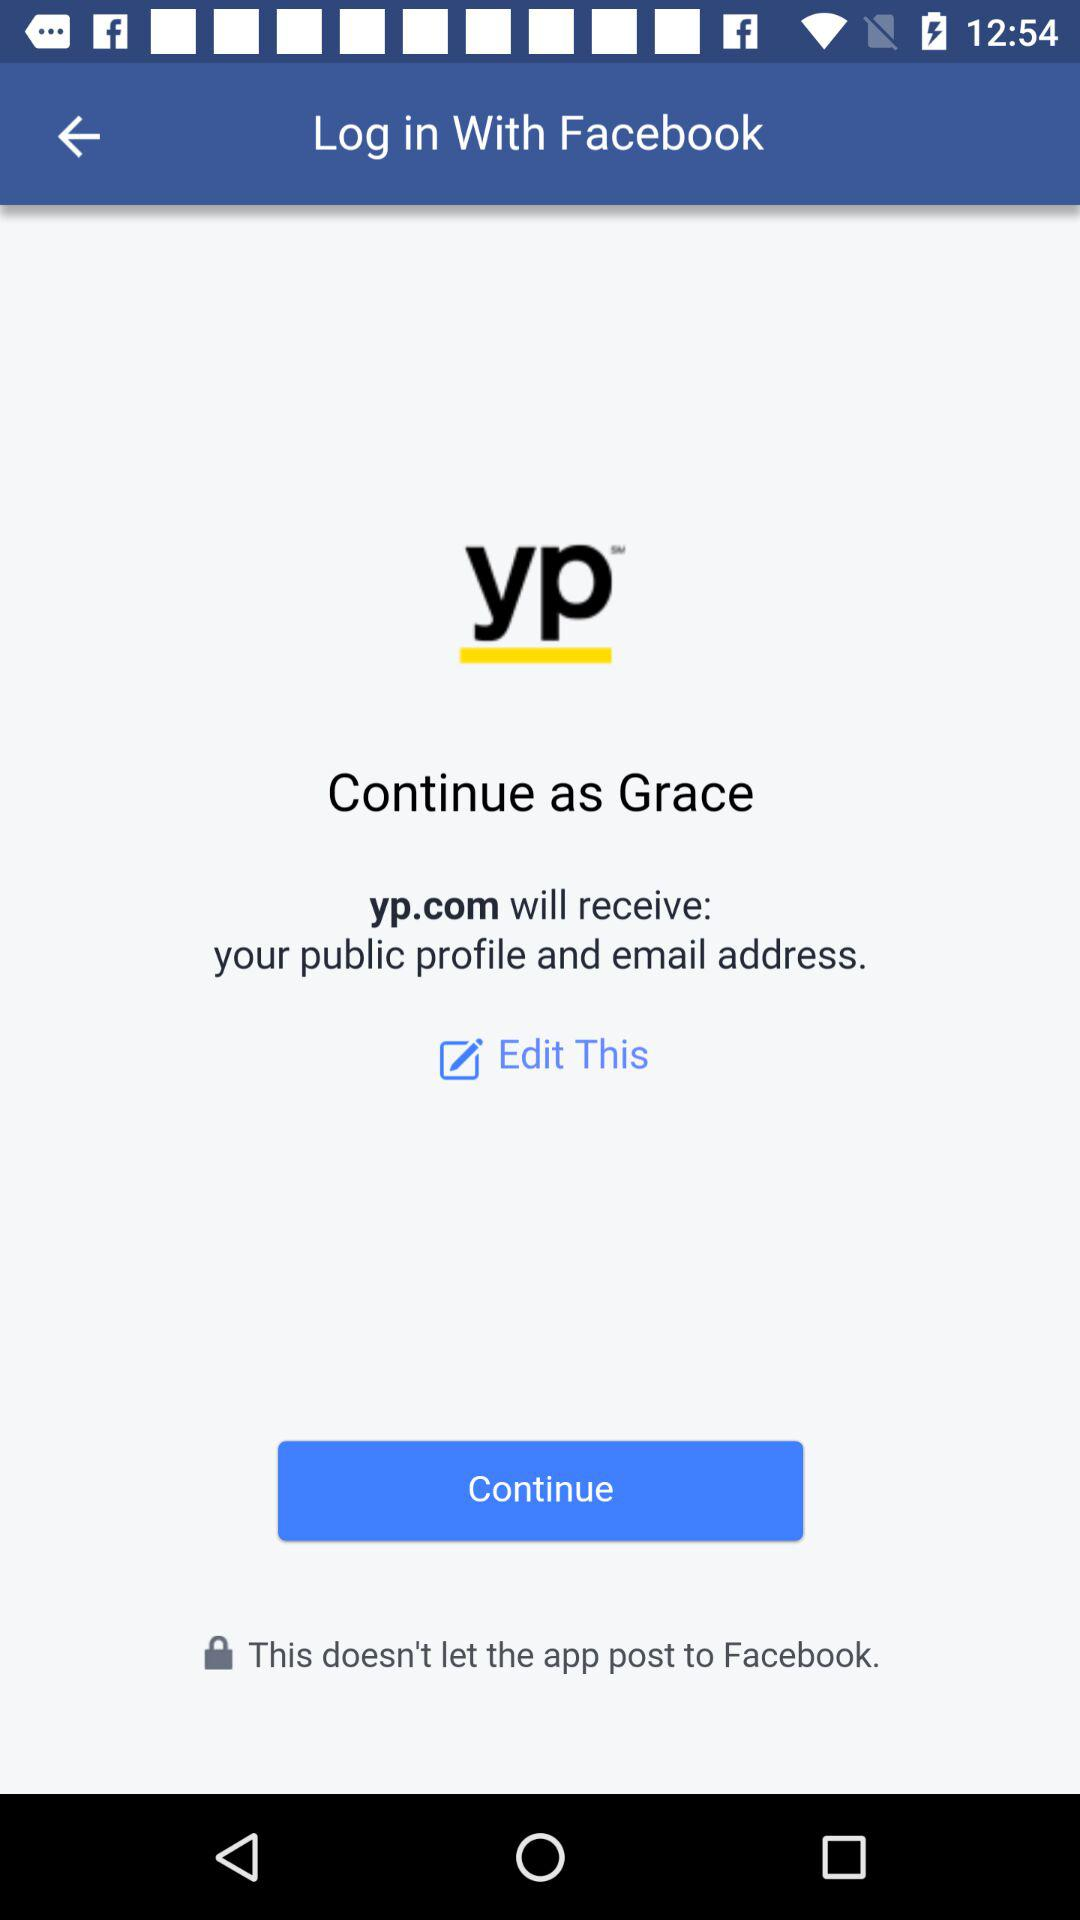What application is asking for permission? The application that is asking for permission is "yp". 